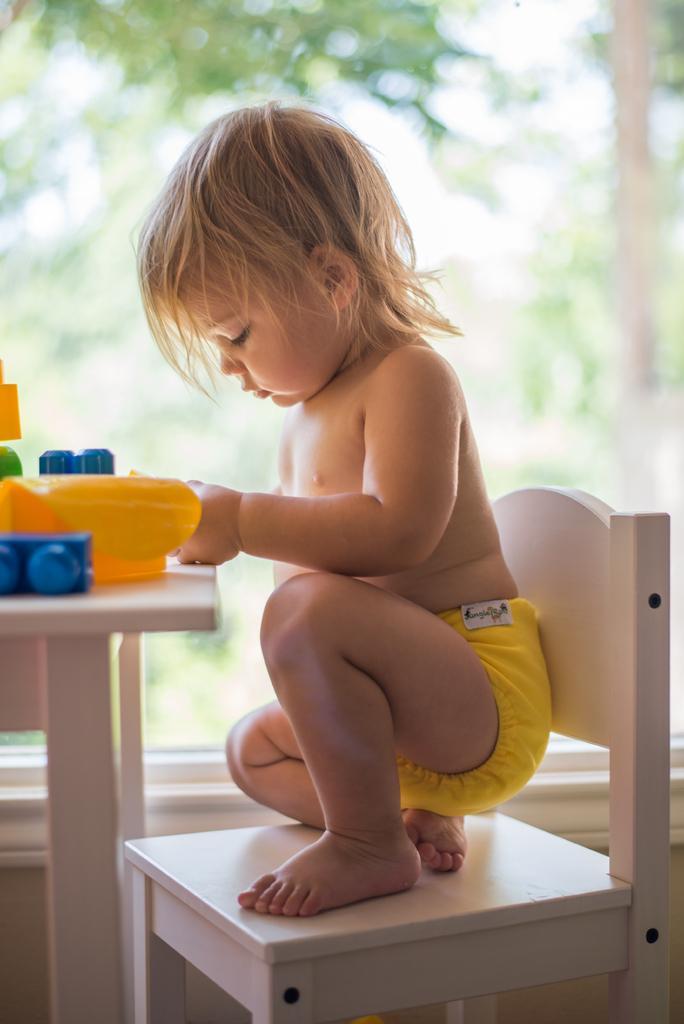In one or two sentences, can you explain what this image depicts? In this image there is a kid sitting in a chair. In front of the table. On the table there are some toys. In the background, there is a tree, sky. The kid is wearing yellow color short. 